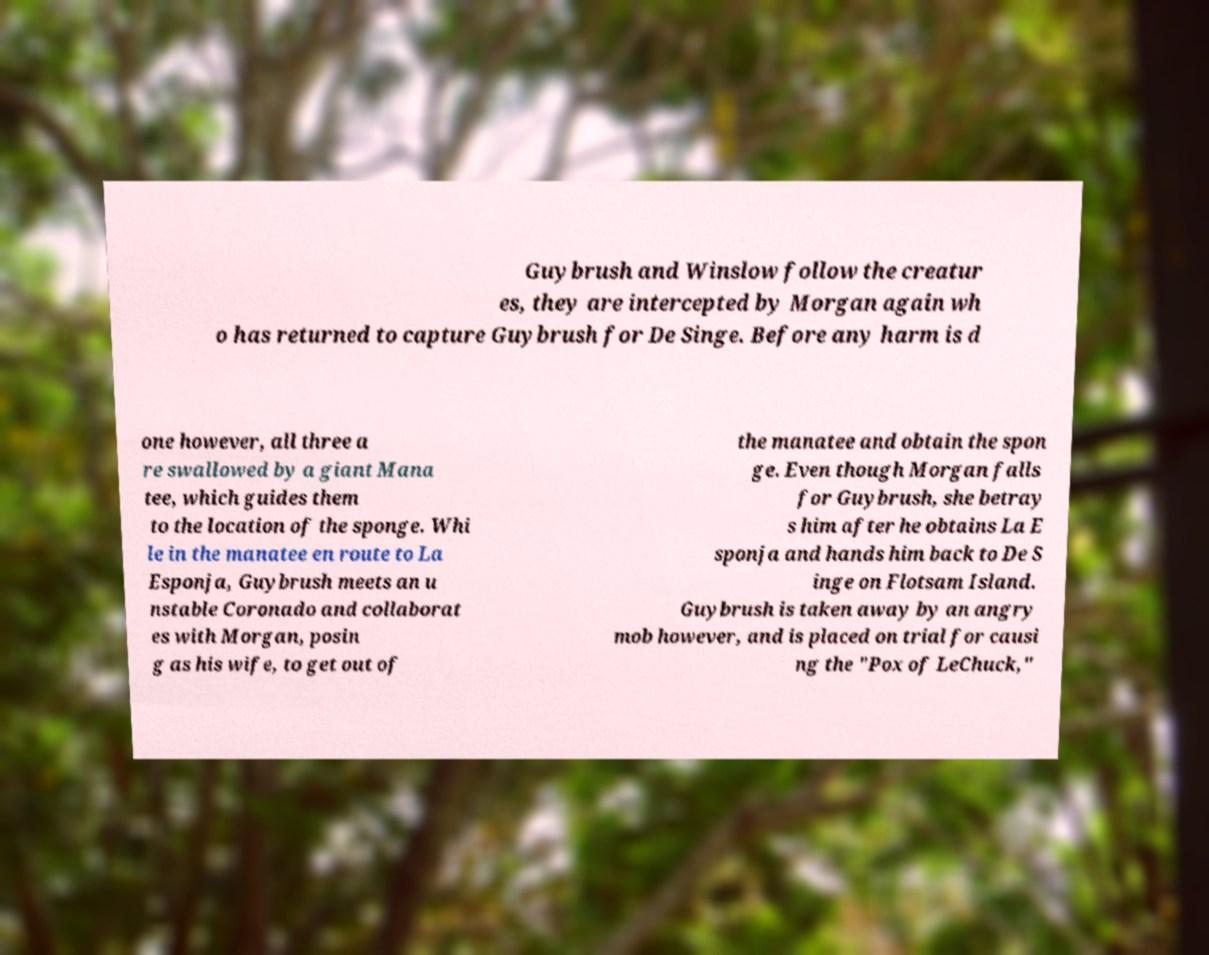Can you read and provide the text displayed in the image?This photo seems to have some interesting text. Can you extract and type it out for me? Guybrush and Winslow follow the creatur es, they are intercepted by Morgan again wh o has returned to capture Guybrush for De Singe. Before any harm is d one however, all three a re swallowed by a giant Mana tee, which guides them to the location of the sponge. Whi le in the manatee en route to La Esponja, Guybrush meets an u nstable Coronado and collaborat es with Morgan, posin g as his wife, to get out of the manatee and obtain the spon ge. Even though Morgan falls for Guybrush, she betray s him after he obtains La E sponja and hands him back to De S inge on Flotsam Island. Guybrush is taken away by an angry mob however, and is placed on trial for causi ng the "Pox of LeChuck," 